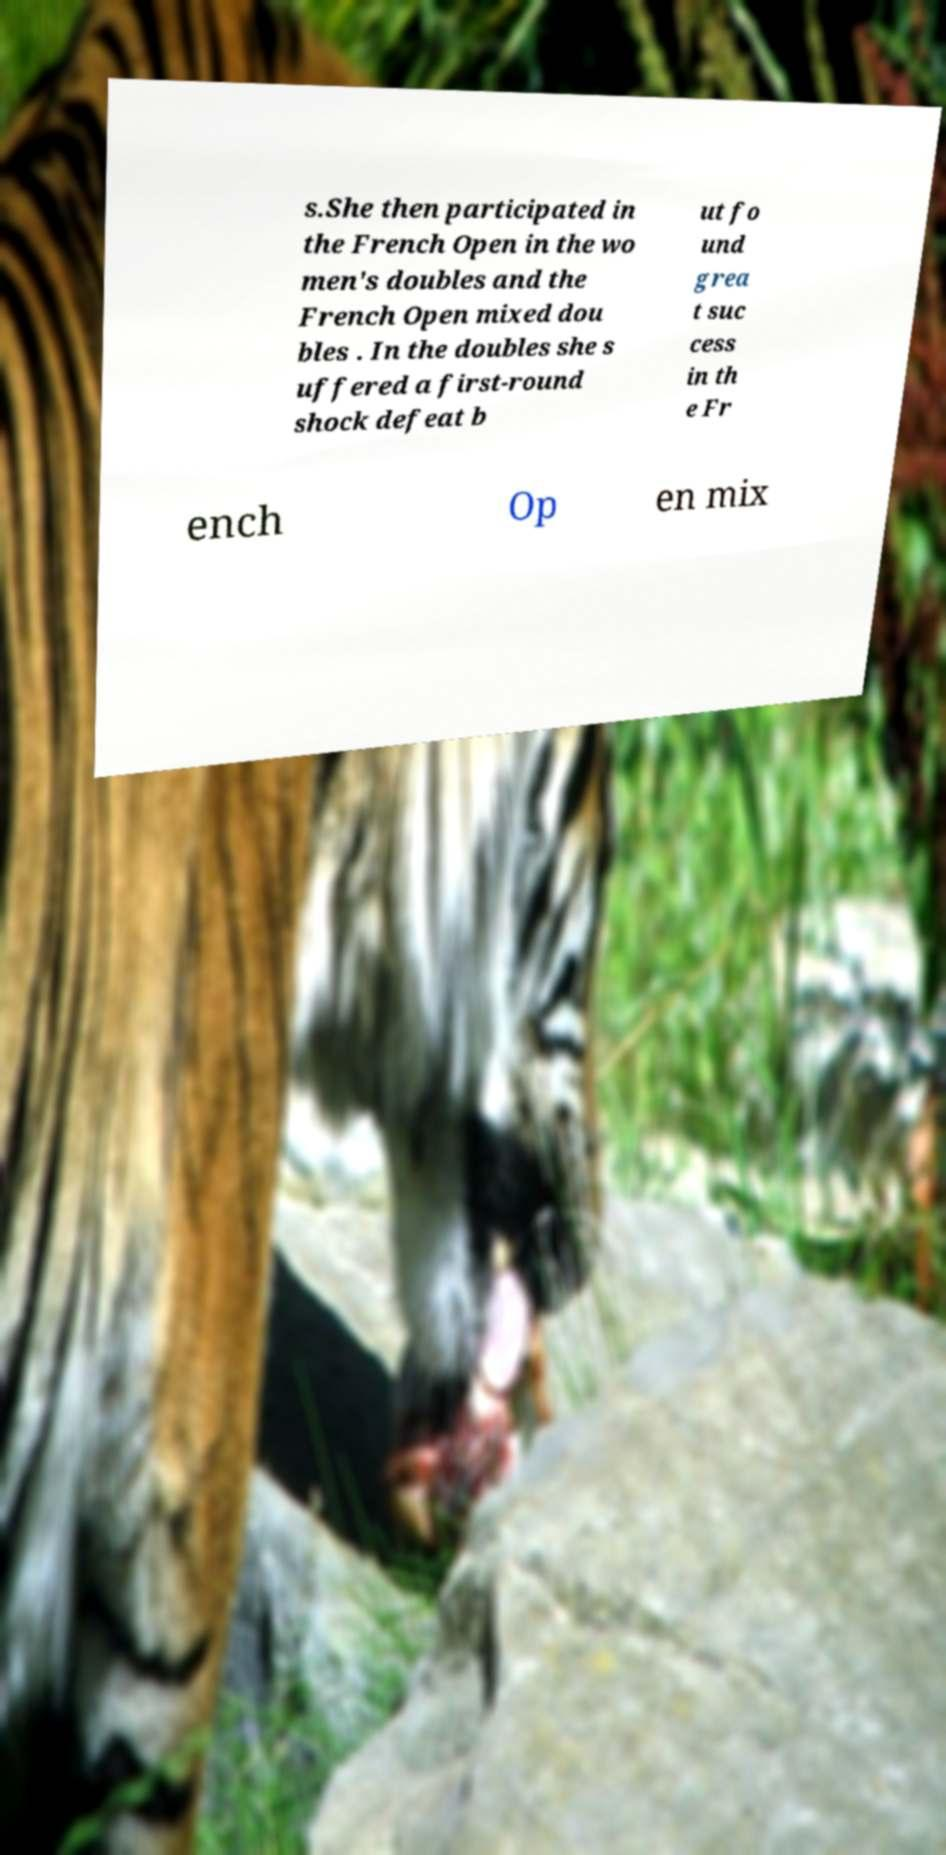Could you assist in decoding the text presented in this image and type it out clearly? s.She then participated in the French Open in the wo men's doubles and the French Open mixed dou bles . In the doubles she s uffered a first-round shock defeat b ut fo und grea t suc cess in th e Fr ench Op en mix 